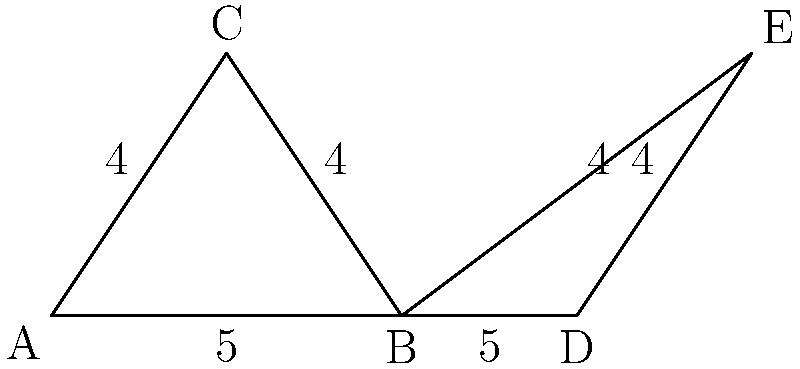In your law library, you've arranged some books to form two triangles on a shelf. Triangle ABC represents constitutional law books, while triangle BDE represents criminal law books. Given that AB = BD = 5 units, and AC = BC = DE = 4 units, prove that these triangles are congruent and identify the congruence criterion used. To prove that triangles ABC and BDE are congruent, we'll follow these steps:

1) First, let's identify the known information:
   - AB = BD = 5 units
   - AC = BC = DE = 4 units

2) Now, let's analyze the triangles:
   - In triangle ABC:
     * AB = 5, AC = BC = 4
   - In triangle BDE:
     * BD = 5, BE = DE = 4

3) We can see that:
   - AB in triangle ABC corresponds to BD in triangle BDE (both = 5)
   - BC in triangle ABC corresponds to BE in triangle BDE (both = 4)
   - AC in triangle ABC corresponds to DE in triangle BDE (both = 4)

4) This means we have three pairs of corresponding sides that are equal:
   - AB = BD
   - BC = BE
   - AC = DE

5) When three sides of one triangle are equal to three sides of another triangle, we can conclude that the triangles are congruent.

6) This congruence criterion is known as the Side-Side-Side (SSS) congruence criterion.

Therefore, triangles ABC and BDE are congruent by the SSS congruence criterion.
Answer: Congruent by SSS 